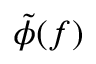<formula> <loc_0><loc_0><loc_500><loc_500>\tilde { \phi } ( f )</formula> 